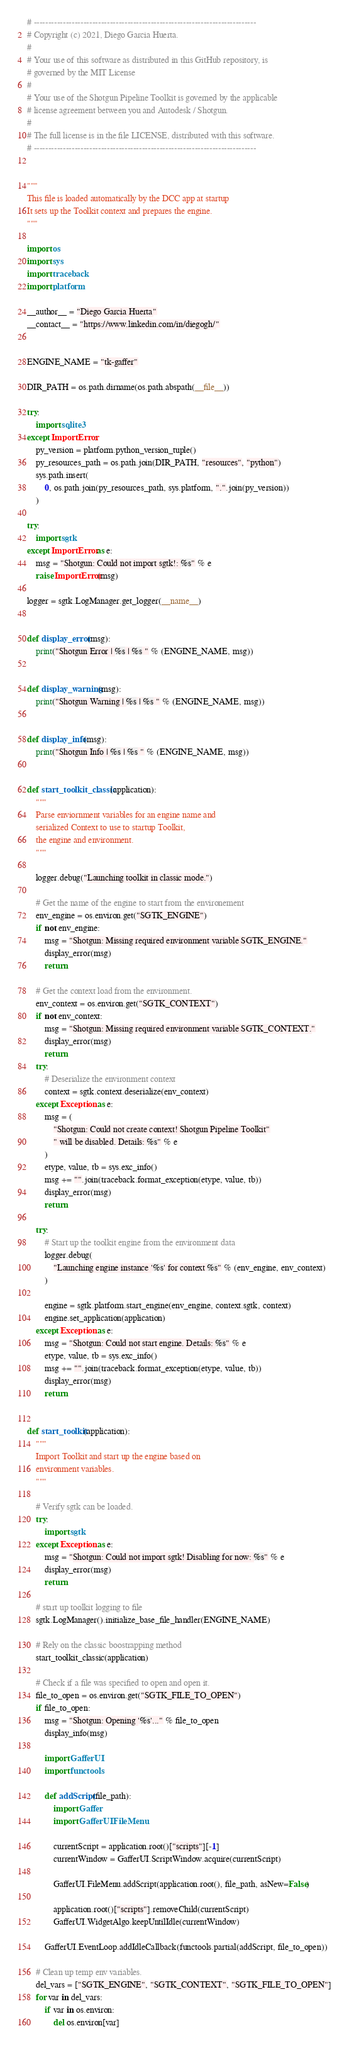<code> <loc_0><loc_0><loc_500><loc_500><_Python_># ----------------------------------------------------------------------------
# Copyright (c) 2021, Diego Garcia Huerta.
#
# Your use of this software as distributed in this GitHub repository, is
# governed by the MIT License
#
# Your use of the Shotgun Pipeline Toolkit is governed by the applicable
# license agreement between you and Autodesk / Shotgun.
#
# The full license is in the file LICENSE, distributed with this software.
# ----------------------------------------------------------------------------


"""
This file is loaded automatically by the DCC app at startup
It sets up the Toolkit context and prepares the engine.
"""

import os
import sys
import traceback
import platform

__author__ = "Diego Garcia Huerta"
__contact__ = "https://www.linkedin.com/in/diegogh/"


ENGINE_NAME = "tk-gaffer"

DIR_PATH = os.path.dirname(os.path.abspath(__file__))

try:
    import sqlite3
except ImportError:
    py_version = platform.python_version_tuple()
    py_resources_path = os.path.join(DIR_PATH, "resources", "python")
    sys.path.insert(
        0, os.path.join(py_resources_path, sys.platform, ".".join(py_version))
    )

try:
    import sgtk
except ImportError as e:
    msg = "Shotgun: Could not import sgtk!: %s" % e
    raise ImportError(msg)

logger = sgtk.LogManager.get_logger(__name__)


def display_error(msg):
    print("Shotgun Error | %s | %s " % (ENGINE_NAME, msg))


def display_warning(msg):
    print("Shotgun Warning | %s | %s " % (ENGINE_NAME, msg))


def display_info(msg):
    print("Shotgun Info | %s | %s " % (ENGINE_NAME, msg))


def start_toolkit_classic(application):
    """
    Parse enviornment variables for an engine name and
    serialized Context to use to startup Toolkit,
    the engine and environment.
    """

    logger.debug("Launching toolkit in classic mode.")

    # Get the name of the engine to start from the environement
    env_engine = os.environ.get("SGTK_ENGINE")
    if not env_engine:
        msg = "Shotgun: Missing required environment variable SGTK_ENGINE."
        display_error(msg)
        return

    # Get the context load from the environment.
    env_context = os.environ.get("SGTK_CONTEXT")
    if not env_context:
        msg = "Shotgun: Missing required environment variable SGTK_CONTEXT."
        display_error(msg)
        return
    try:
        # Deserialize the environment context
        context = sgtk.context.deserialize(env_context)
    except Exception as e:
        msg = (
            "Shotgun: Could not create context! Shotgun Pipeline Toolkit"
            " will be disabled. Details: %s" % e
        )
        etype, value, tb = sys.exc_info()
        msg += "".join(traceback.format_exception(etype, value, tb))
        display_error(msg)
        return

    try:
        # Start up the toolkit engine from the environment data
        logger.debug(
            "Launching engine instance '%s' for context %s" % (env_engine, env_context)
        )

        engine = sgtk.platform.start_engine(env_engine, context.sgtk, context)
        engine.set_application(application)
    except Exception as e:
        msg = "Shotgun: Could not start engine. Details: %s" % e
        etype, value, tb = sys.exc_info()
        msg += "".join(traceback.format_exception(etype, value, tb))
        display_error(msg)
        return


def start_toolkit(application):
    """
    Import Toolkit and start up the engine based on
    environment variables.
    """

    # Verify sgtk can be loaded.
    try:
        import sgtk
    except Exception as e:
        msg = "Shotgun: Could not import sgtk! Disabling for now: %s" % e
        display_error(msg)
        return

    # start up toolkit logging to file
    sgtk.LogManager().initialize_base_file_handler(ENGINE_NAME)

    # Rely on the classic boostrapping method
    start_toolkit_classic(application)

    # Check if a file was specified to open and open it.
    file_to_open = os.environ.get("SGTK_FILE_TO_OPEN")
    if file_to_open:
        msg = "Shotgun: Opening '%s'..." % file_to_open
        display_info(msg)

        import GafferUI
        import functools

        def addScript(file_path):
            import Gaffer
            import GafferUI.FileMenu

            currentScript = application.root()["scripts"][-1]
            currentWindow = GafferUI.ScriptWindow.acquire(currentScript)

            GafferUI.FileMenu.addScript(application.root(), file_path, asNew=False)

            application.root()["scripts"].removeChild(currentScript)
            GafferUI.WidgetAlgo.keepUntilIdle(currentWindow)

        GafferUI.EventLoop.addIdleCallback(functools.partial(addScript, file_to_open))

    # Clean up temp env variables.
    del_vars = ["SGTK_ENGINE", "SGTK_CONTEXT", "SGTK_FILE_TO_OPEN"]
    for var in del_vars:
        if var in os.environ:
            del os.environ[var]
</code> 